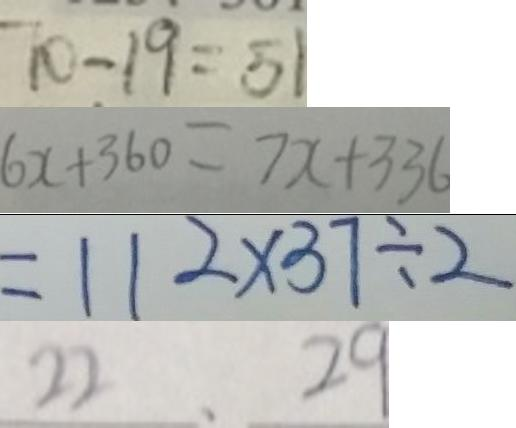Convert formula to latex. <formula><loc_0><loc_0><loc_500><loc_500>7 0 - 1 9 = 5 1 
 6 x + 3 6 0 = 7 x + 3 3 6 
 = 1 1 2 \times 3 7 \div 2 
 2 2 . 2 9</formula> 